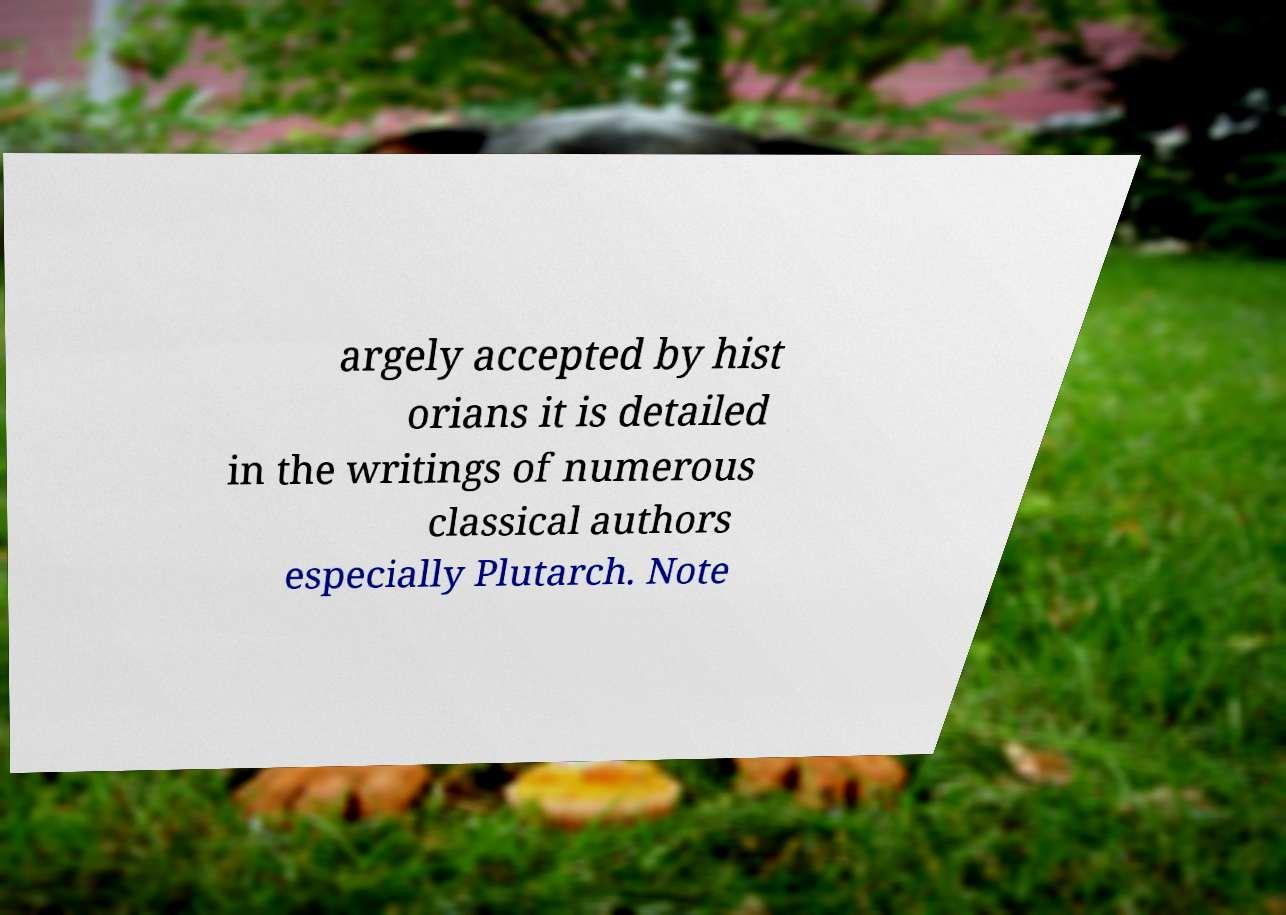Could you assist in decoding the text presented in this image and type it out clearly? argely accepted by hist orians it is detailed in the writings of numerous classical authors especially Plutarch. Note 